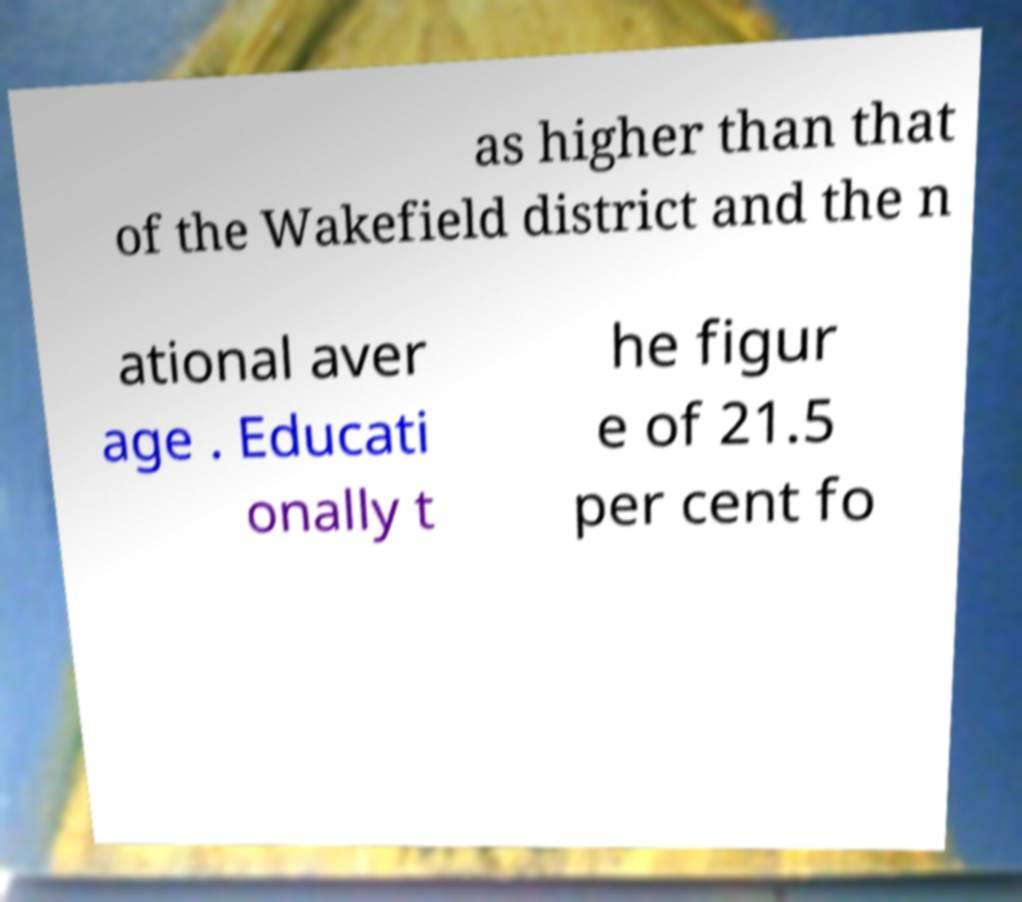Please read and relay the text visible in this image. What does it say? as higher than that of the Wakefield district and the n ational aver age . Educati onally t he figur e of 21.5 per cent fo 